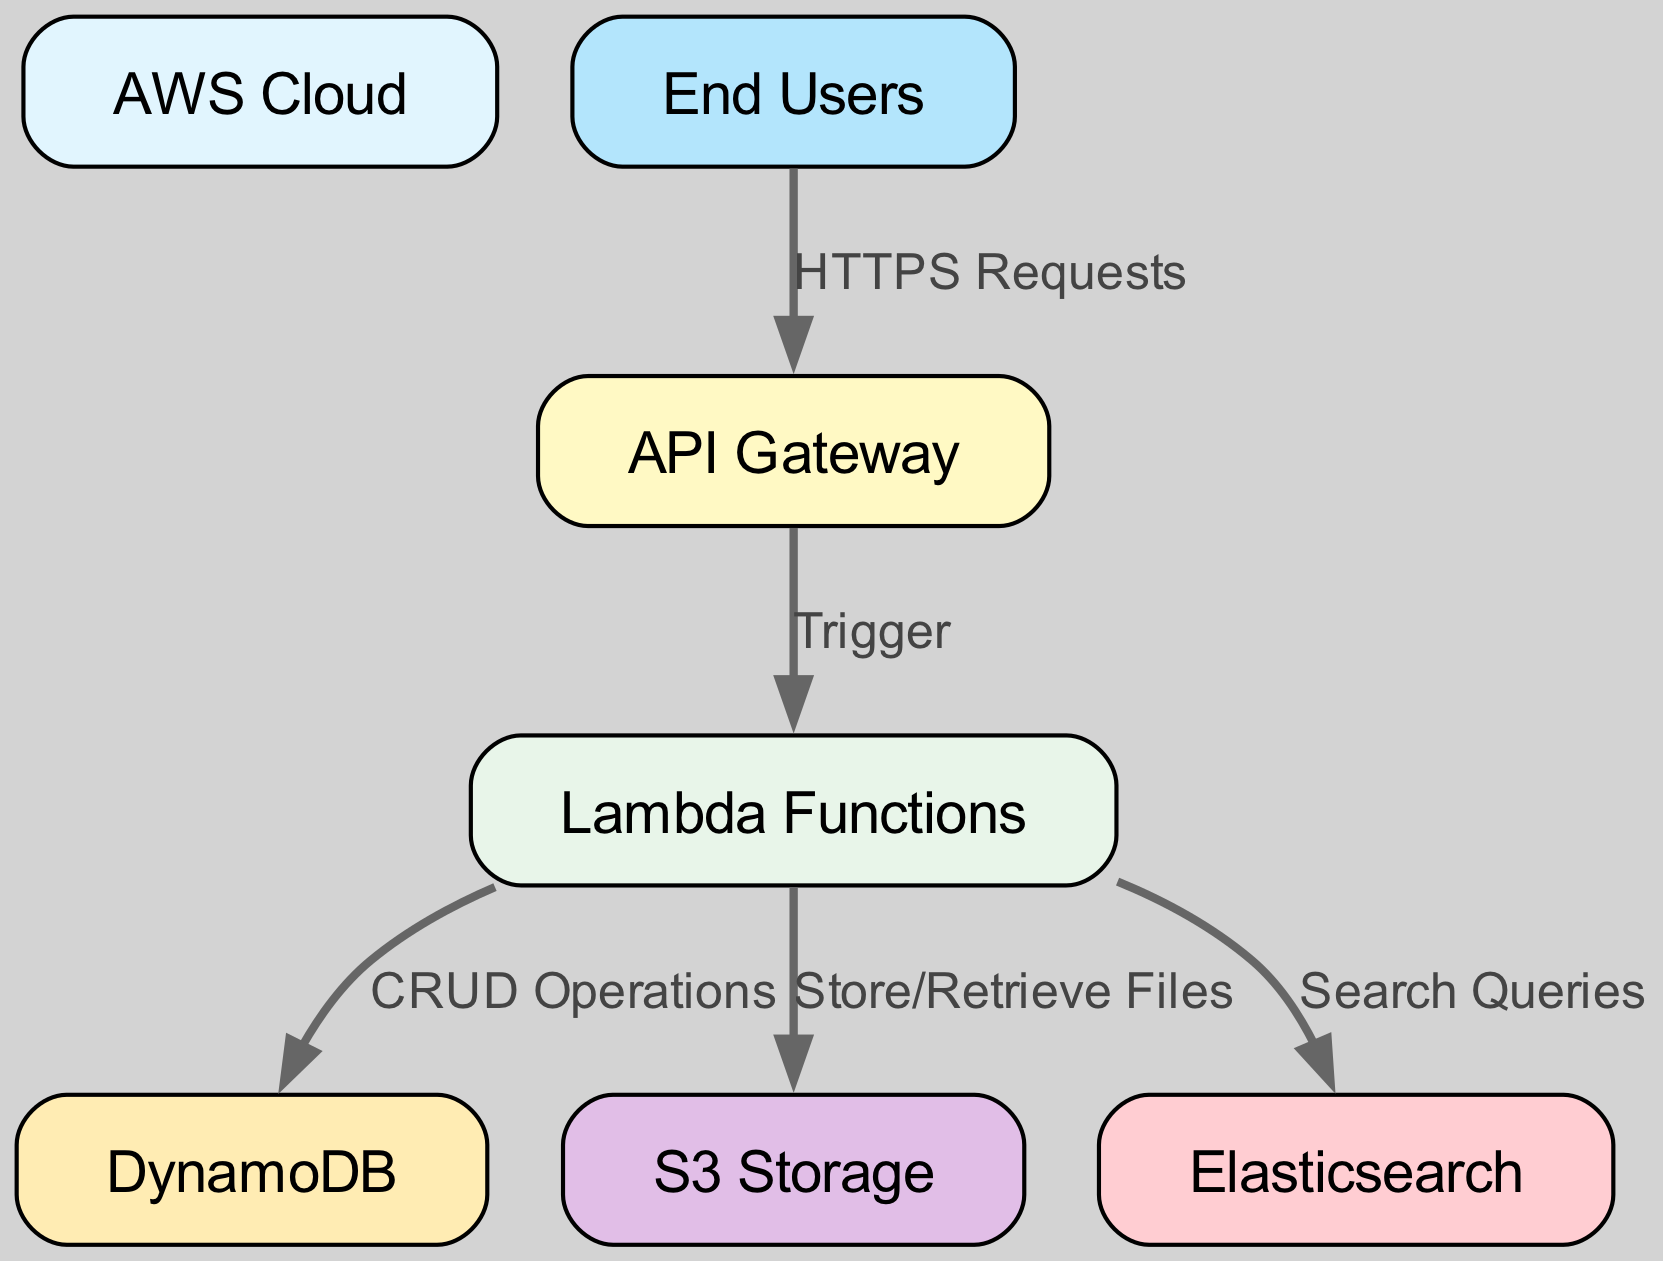What is the total number of nodes in the diagram? The diagram lists 7 individual components that can be identified as nodes: AWS Cloud, API Gateway, Lambda Functions, DynamoDB, S3 Storage, Elasticsearch, and End Users. Counting these gives a total of 7 nodes.
Answer: 7 What is the label of the node connected to "API Gateway"? The API Gateway node is connected to the Lambda Functions node. The diagram specifies that the API Gateway triggers Lambda Functions in the data flow. Therefore, the label of the connected node is "Lambda Functions".
Answer: Lambda Functions How many edges originate from the "Lambda Functions" node? Upon inspecting the diagram, we can see that there are three edges that originate from the Lambda Functions node: one to DynamoDB (for CRUD Operations), one to S3 Storage (for Store/Retrieve Files), and one to Elasticsearch (for Search Queries). Therefore, the count of edges originating from this node is 3.
Answer: 3 What type of requests do "End Users" make to the "API Gateway"? The diagram clearly shows that the End Users make "HTTPS Requests" to the API Gateway. This relationship is defined by the edge between these two nodes.
Answer: HTTPS Requests What is the relationship between "Lambda Functions" and "DynamoDB"? The relationship between these two nodes is defined as "CRUD Operations". This means that Lambda Functions perform Create, Read, Update, and Delete operations on the DynamoDB database, which reflects the flow of data between them.
Answer: CRUD Operations Which node acts as a storage component in this cloud infrastructure? The diagram indicates that "S3 Storage" serves as the storage component in the cloud infrastructure, which is dedicated to storing and retrieving files as indicated in the edges leading from Lambda Functions to S3 Storage.
Answer: S3 Storage Identify the flow direction of data starting from "End Users". Starting from the End Users node, data flows to the API Gateway via HTTPS Requests. From the API Gateway, the flow continues to Lambda Functions, which then directs data to DynamoDB, S3 Storage, and Elasticsearch based on various operations performed. The overall direction of data flow is downward and forward, culminating in these various connections.
Answer: Downward and forward 